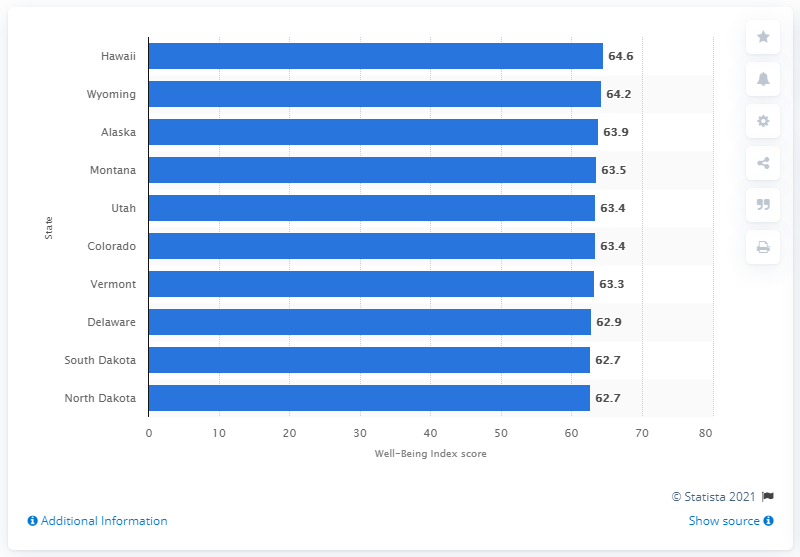Indicate a few pertinent items in this graphic. According to the Well-Being Index score in 2018, Hawaii had the highest overall ranking among all states in the United States. 